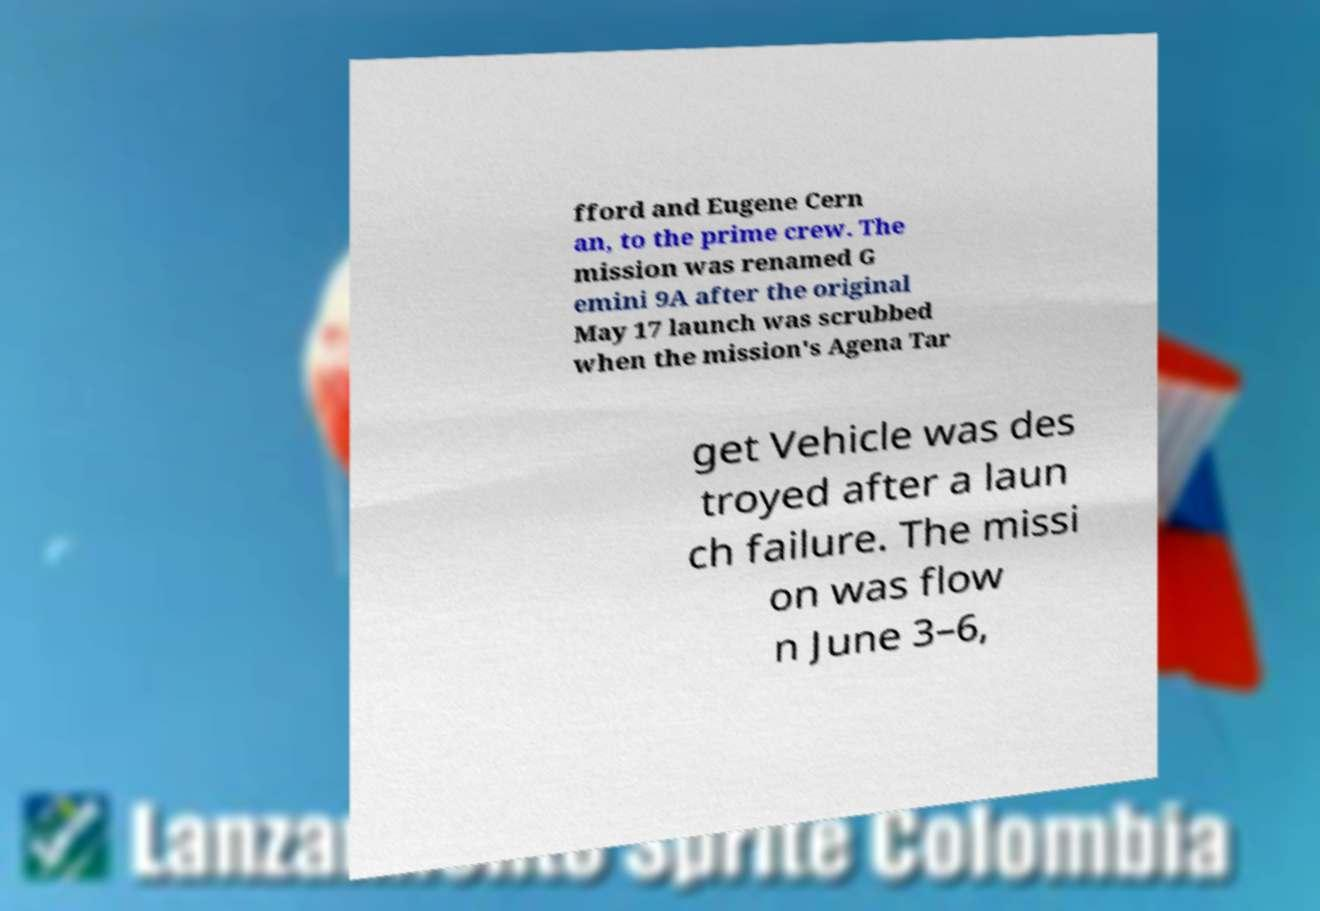Please identify and transcribe the text found in this image. fford and Eugene Cern an, to the prime crew. The mission was renamed G emini 9A after the original May 17 launch was scrubbed when the mission's Agena Tar get Vehicle was des troyed after a laun ch failure. The missi on was flow n June 3–6, 